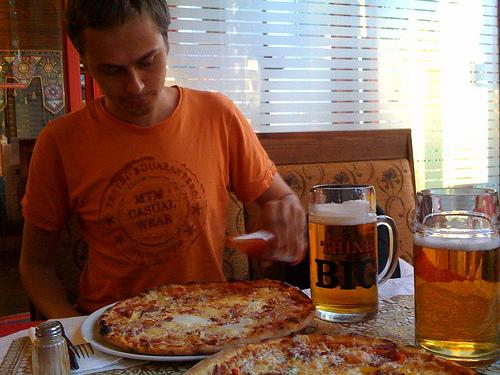Question: who is pictured?
Choices:
A. A woman.
B. A baby.
C. A teenage boy.
D. A man.
Answer with the letter. Answer: D Question: what is he drinking?
Choices:
A. Wine.
B. Beer.
C. Soda.
D. Milk.
Answer with the letter. Answer: B Question: where was this taken?
Choices:
A. At the park.
B. In a kitchen.
C. At a restaurant.
D. In the mountains.
Answer with the letter. Answer: C Question: how many mugs of beer are on the table?
Choices:
A. One.
B. Two.
C. Five.
D. Three.
Answer with the letter. Answer: B Question: what is the food on his plate?
Choices:
A. Chicken.
B. Pizza.
C. Salad.
D. Carrots.
Answer with the letter. Answer: B 